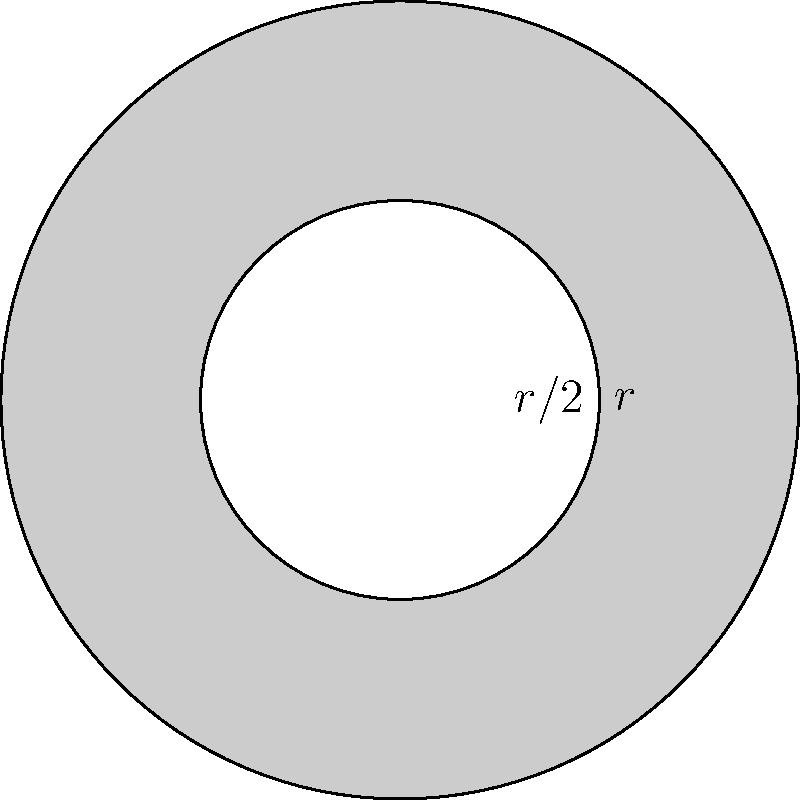A circular logo for a web development company consists of a large circle with radius $r$ and a smaller concentric circle with radius $r/2$. The area between the two circles is shaded gray. If the total area of the logo is 36π square units, what is the area of the shaded region in square units? Let's approach this step-by-step:

1) First, we need to find the radius $r$ of the outer circle:
   Area of outer circle = $\pi r^2 = 36\pi$
   $r^2 = 36$
   $r = 6$ units

2) Now we know:
   - Radius of outer circle = 6 units
   - Radius of inner circle = $6/2 = 3$ units

3) Area of outer circle:
   $A_{outer} = \pi r^2 = \pi (6)^2 = 36\pi$ sq units

4) Area of inner circle:
   $A_{inner} = \pi (r/2)^2 = \pi (3)^2 = 9\pi$ sq units

5) The shaded area is the difference between these two:
   $A_{shaded} = A_{outer} - A_{inner} = 36\pi - 9\pi = 27\pi$ sq units

Therefore, the area of the shaded region is $27\pi$ square units.
Answer: $27\pi$ sq units 